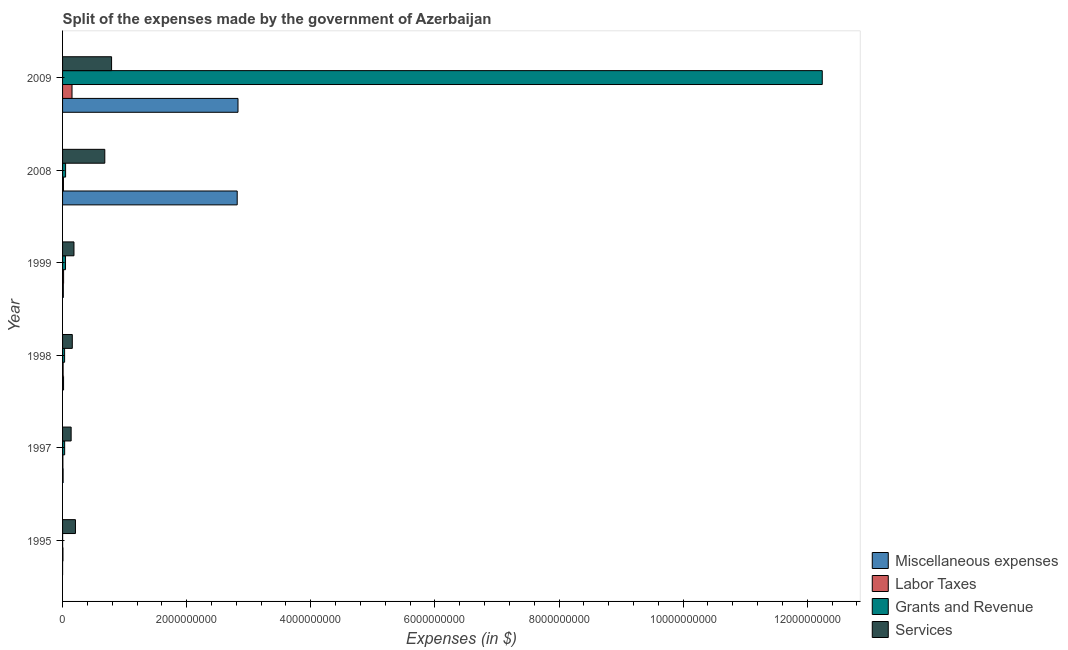Are the number of bars per tick equal to the number of legend labels?
Offer a very short reply. Yes. In how many cases, is the number of bars for a given year not equal to the number of legend labels?
Give a very brief answer. 0. What is the amount spent on miscellaneous expenses in 1999?
Offer a terse response. 1.23e+07. Across all years, what is the maximum amount spent on miscellaneous expenses?
Your answer should be very brief. 2.83e+09. Across all years, what is the minimum amount spent on grants and revenue?
Offer a terse response. 9.45e+05. In which year was the amount spent on labor taxes maximum?
Offer a very short reply. 2009. In which year was the amount spent on miscellaneous expenses minimum?
Make the answer very short. 1995. What is the total amount spent on labor taxes in the graph?
Ensure brevity in your answer.  2.03e+08. What is the difference between the amount spent on grants and revenue in 1999 and that in 2009?
Your response must be concise. -1.22e+1. What is the difference between the amount spent on grants and revenue in 1997 and the amount spent on miscellaneous expenses in 1998?
Make the answer very short. 1.76e+07. What is the average amount spent on miscellaneous expenses per year?
Make the answer very short. 9.46e+08. In the year 2009, what is the difference between the amount spent on miscellaneous expenses and amount spent on labor taxes?
Offer a very short reply. 2.67e+09. What is the ratio of the amount spent on labor taxes in 1997 to that in 1999?
Your answer should be compact. 0.31. Is the amount spent on miscellaneous expenses in 1999 less than that in 2008?
Make the answer very short. Yes. Is the difference between the amount spent on grants and revenue in 1999 and 2008 greater than the difference between the amount spent on labor taxes in 1999 and 2008?
Ensure brevity in your answer.  No. What is the difference between the highest and the second highest amount spent on miscellaneous expenses?
Your response must be concise. 1.29e+07. What is the difference between the highest and the lowest amount spent on miscellaneous expenses?
Your response must be concise. 2.83e+09. What does the 1st bar from the top in 1998 represents?
Keep it short and to the point. Services. What does the 1st bar from the bottom in 1997 represents?
Offer a very short reply. Miscellaneous expenses. How many bars are there?
Keep it short and to the point. 24. What is the difference between two consecutive major ticks on the X-axis?
Your response must be concise. 2.00e+09. Are the values on the major ticks of X-axis written in scientific E-notation?
Your answer should be compact. No. Does the graph contain grids?
Give a very brief answer. No. Where does the legend appear in the graph?
Keep it short and to the point. Bottom right. What is the title of the graph?
Ensure brevity in your answer.  Split of the expenses made by the government of Azerbaijan. Does "Other greenhouse gases" appear as one of the legend labels in the graph?
Ensure brevity in your answer.  No. What is the label or title of the X-axis?
Provide a succinct answer. Expenses (in $). What is the label or title of the Y-axis?
Provide a short and direct response. Year. What is the Expenses (in $) in Miscellaneous expenses in 1995?
Offer a terse response. 3.14e+05. What is the Expenses (in $) of Labor Taxes in 1995?
Offer a very short reply. 6.16e+06. What is the Expenses (in $) in Grants and Revenue in 1995?
Make the answer very short. 9.45e+05. What is the Expenses (in $) of Services in 1995?
Provide a short and direct response. 2.08e+08. What is the Expenses (in $) in Miscellaneous expenses in 1997?
Offer a terse response. 8.71e+06. What is the Expenses (in $) of Labor Taxes in 1997?
Your answer should be compact. 5.17e+06. What is the Expenses (in $) in Grants and Revenue in 1997?
Your answer should be compact. 3.36e+07. What is the Expenses (in $) of Services in 1997?
Keep it short and to the point. 1.38e+08. What is the Expenses (in $) in Miscellaneous expenses in 1998?
Offer a terse response. 1.60e+07. What is the Expenses (in $) of Labor Taxes in 1998?
Offer a terse response. 8.90e+06. What is the Expenses (in $) of Grants and Revenue in 1998?
Ensure brevity in your answer.  3.29e+07. What is the Expenses (in $) of Services in 1998?
Offer a very short reply. 1.57e+08. What is the Expenses (in $) in Miscellaneous expenses in 1999?
Your answer should be compact. 1.23e+07. What is the Expenses (in $) of Labor Taxes in 1999?
Ensure brevity in your answer.  1.66e+07. What is the Expenses (in $) in Grants and Revenue in 1999?
Give a very brief answer. 4.76e+07. What is the Expenses (in $) in Services in 1999?
Give a very brief answer. 1.84e+08. What is the Expenses (in $) in Miscellaneous expenses in 2008?
Offer a terse response. 2.81e+09. What is the Expenses (in $) in Labor Taxes in 2008?
Provide a short and direct response. 1.43e+07. What is the Expenses (in $) in Grants and Revenue in 2008?
Ensure brevity in your answer.  4.87e+07. What is the Expenses (in $) of Services in 2008?
Provide a short and direct response. 6.80e+08. What is the Expenses (in $) in Miscellaneous expenses in 2009?
Make the answer very short. 2.83e+09. What is the Expenses (in $) of Labor Taxes in 2009?
Your answer should be very brief. 1.52e+08. What is the Expenses (in $) of Grants and Revenue in 2009?
Your response must be concise. 1.22e+1. What is the Expenses (in $) in Services in 2009?
Provide a short and direct response. 7.90e+08. Across all years, what is the maximum Expenses (in $) of Miscellaneous expenses?
Make the answer very short. 2.83e+09. Across all years, what is the maximum Expenses (in $) of Labor Taxes?
Keep it short and to the point. 1.52e+08. Across all years, what is the maximum Expenses (in $) in Grants and Revenue?
Your answer should be compact. 1.22e+1. Across all years, what is the maximum Expenses (in $) of Services?
Your response must be concise. 7.90e+08. Across all years, what is the minimum Expenses (in $) of Miscellaneous expenses?
Provide a short and direct response. 3.14e+05. Across all years, what is the minimum Expenses (in $) of Labor Taxes?
Provide a succinct answer. 5.17e+06. Across all years, what is the minimum Expenses (in $) of Grants and Revenue?
Offer a terse response. 9.45e+05. Across all years, what is the minimum Expenses (in $) in Services?
Provide a short and direct response. 1.38e+08. What is the total Expenses (in $) of Miscellaneous expenses in the graph?
Make the answer very short. 5.68e+09. What is the total Expenses (in $) in Labor Taxes in the graph?
Your answer should be very brief. 2.03e+08. What is the total Expenses (in $) of Grants and Revenue in the graph?
Offer a very short reply. 1.24e+1. What is the total Expenses (in $) in Services in the graph?
Ensure brevity in your answer.  2.16e+09. What is the difference between the Expenses (in $) in Miscellaneous expenses in 1995 and that in 1997?
Keep it short and to the point. -8.39e+06. What is the difference between the Expenses (in $) of Labor Taxes in 1995 and that in 1997?
Offer a terse response. 9.89e+05. What is the difference between the Expenses (in $) in Grants and Revenue in 1995 and that in 1997?
Provide a succinct answer. -3.27e+07. What is the difference between the Expenses (in $) of Services in 1995 and that in 1997?
Provide a succinct answer. 6.93e+07. What is the difference between the Expenses (in $) of Miscellaneous expenses in 1995 and that in 1998?
Keep it short and to the point. -1.57e+07. What is the difference between the Expenses (in $) of Labor Taxes in 1995 and that in 1998?
Your response must be concise. -2.74e+06. What is the difference between the Expenses (in $) of Grants and Revenue in 1995 and that in 1998?
Your response must be concise. -3.20e+07. What is the difference between the Expenses (in $) in Services in 1995 and that in 1998?
Ensure brevity in your answer.  5.07e+07. What is the difference between the Expenses (in $) of Miscellaneous expenses in 1995 and that in 1999?
Offer a terse response. -1.20e+07. What is the difference between the Expenses (in $) in Labor Taxes in 1995 and that in 1999?
Make the answer very short. -1.05e+07. What is the difference between the Expenses (in $) in Grants and Revenue in 1995 and that in 1999?
Give a very brief answer. -4.66e+07. What is the difference between the Expenses (in $) in Services in 1995 and that in 1999?
Offer a very short reply. 2.38e+07. What is the difference between the Expenses (in $) in Miscellaneous expenses in 1995 and that in 2008?
Offer a very short reply. -2.81e+09. What is the difference between the Expenses (in $) of Labor Taxes in 1995 and that in 2008?
Your answer should be very brief. -8.10e+06. What is the difference between the Expenses (in $) in Grants and Revenue in 1995 and that in 2008?
Keep it short and to the point. -4.78e+07. What is the difference between the Expenses (in $) of Services in 1995 and that in 2008?
Your answer should be compact. -4.73e+08. What is the difference between the Expenses (in $) in Miscellaneous expenses in 1995 and that in 2009?
Keep it short and to the point. -2.83e+09. What is the difference between the Expenses (in $) in Labor Taxes in 1995 and that in 2009?
Offer a terse response. -1.46e+08. What is the difference between the Expenses (in $) in Grants and Revenue in 1995 and that in 2009?
Provide a short and direct response. -1.22e+1. What is the difference between the Expenses (in $) in Services in 1995 and that in 2009?
Your answer should be compact. -5.82e+08. What is the difference between the Expenses (in $) of Miscellaneous expenses in 1997 and that in 1998?
Your answer should be very brief. -7.34e+06. What is the difference between the Expenses (in $) of Labor Taxes in 1997 and that in 1998?
Provide a succinct answer. -3.73e+06. What is the difference between the Expenses (in $) of Grants and Revenue in 1997 and that in 1998?
Offer a very short reply. 7.00e+05. What is the difference between the Expenses (in $) of Services in 1997 and that in 1998?
Offer a terse response. -1.86e+07. What is the difference between the Expenses (in $) in Miscellaneous expenses in 1997 and that in 1999?
Offer a terse response. -3.57e+06. What is the difference between the Expenses (in $) in Labor Taxes in 1997 and that in 1999?
Keep it short and to the point. -1.14e+07. What is the difference between the Expenses (in $) in Grants and Revenue in 1997 and that in 1999?
Give a very brief answer. -1.40e+07. What is the difference between the Expenses (in $) in Services in 1997 and that in 1999?
Your answer should be compact. -4.55e+07. What is the difference between the Expenses (in $) in Miscellaneous expenses in 1997 and that in 2008?
Keep it short and to the point. -2.81e+09. What is the difference between the Expenses (in $) of Labor Taxes in 1997 and that in 2008?
Keep it short and to the point. -9.09e+06. What is the difference between the Expenses (in $) of Grants and Revenue in 1997 and that in 2008?
Keep it short and to the point. -1.51e+07. What is the difference between the Expenses (in $) of Services in 1997 and that in 2008?
Your answer should be very brief. -5.42e+08. What is the difference between the Expenses (in $) in Miscellaneous expenses in 1997 and that in 2009?
Your answer should be very brief. -2.82e+09. What is the difference between the Expenses (in $) of Labor Taxes in 1997 and that in 2009?
Provide a succinct answer. -1.47e+08. What is the difference between the Expenses (in $) of Grants and Revenue in 1997 and that in 2009?
Offer a terse response. -1.22e+1. What is the difference between the Expenses (in $) of Services in 1997 and that in 2009?
Provide a short and direct response. -6.52e+08. What is the difference between the Expenses (in $) in Miscellaneous expenses in 1998 and that in 1999?
Keep it short and to the point. 3.77e+06. What is the difference between the Expenses (in $) in Labor Taxes in 1998 and that in 1999?
Your answer should be very brief. -7.72e+06. What is the difference between the Expenses (in $) in Grants and Revenue in 1998 and that in 1999?
Ensure brevity in your answer.  -1.47e+07. What is the difference between the Expenses (in $) in Services in 1998 and that in 1999?
Your answer should be very brief. -2.69e+07. What is the difference between the Expenses (in $) of Miscellaneous expenses in 1998 and that in 2008?
Give a very brief answer. -2.80e+09. What is the difference between the Expenses (in $) of Labor Taxes in 1998 and that in 2008?
Keep it short and to the point. -5.36e+06. What is the difference between the Expenses (in $) in Grants and Revenue in 1998 and that in 2008?
Offer a terse response. -1.58e+07. What is the difference between the Expenses (in $) of Services in 1998 and that in 2008?
Provide a succinct answer. -5.24e+08. What is the difference between the Expenses (in $) of Miscellaneous expenses in 1998 and that in 2009?
Keep it short and to the point. -2.81e+09. What is the difference between the Expenses (in $) in Labor Taxes in 1998 and that in 2009?
Keep it short and to the point. -1.43e+08. What is the difference between the Expenses (in $) in Grants and Revenue in 1998 and that in 2009?
Offer a terse response. -1.22e+1. What is the difference between the Expenses (in $) of Services in 1998 and that in 2009?
Your response must be concise. -6.33e+08. What is the difference between the Expenses (in $) of Miscellaneous expenses in 1999 and that in 2008?
Ensure brevity in your answer.  -2.80e+09. What is the difference between the Expenses (in $) of Labor Taxes in 1999 and that in 2008?
Your response must be concise. 2.36e+06. What is the difference between the Expenses (in $) of Grants and Revenue in 1999 and that in 2008?
Offer a very short reply. -1.16e+06. What is the difference between the Expenses (in $) in Services in 1999 and that in 2008?
Your response must be concise. -4.97e+08. What is the difference between the Expenses (in $) in Miscellaneous expenses in 1999 and that in 2009?
Keep it short and to the point. -2.81e+09. What is the difference between the Expenses (in $) of Labor Taxes in 1999 and that in 2009?
Your answer should be very brief. -1.36e+08. What is the difference between the Expenses (in $) of Grants and Revenue in 1999 and that in 2009?
Offer a terse response. -1.22e+1. What is the difference between the Expenses (in $) in Services in 1999 and that in 2009?
Ensure brevity in your answer.  -6.06e+08. What is the difference between the Expenses (in $) of Miscellaneous expenses in 2008 and that in 2009?
Provide a succinct answer. -1.29e+07. What is the difference between the Expenses (in $) in Labor Taxes in 2008 and that in 2009?
Your response must be concise. -1.38e+08. What is the difference between the Expenses (in $) of Grants and Revenue in 2008 and that in 2009?
Your response must be concise. -1.22e+1. What is the difference between the Expenses (in $) of Services in 2008 and that in 2009?
Provide a succinct answer. -1.09e+08. What is the difference between the Expenses (in $) of Miscellaneous expenses in 1995 and the Expenses (in $) of Labor Taxes in 1997?
Keep it short and to the point. -4.86e+06. What is the difference between the Expenses (in $) of Miscellaneous expenses in 1995 and the Expenses (in $) of Grants and Revenue in 1997?
Make the answer very short. -3.33e+07. What is the difference between the Expenses (in $) of Miscellaneous expenses in 1995 and the Expenses (in $) of Services in 1997?
Offer a terse response. -1.38e+08. What is the difference between the Expenses (in $) in Labor Taxes in 1995 and the Expenses (in $) in Grants and Revenue in 1997?
Make the answer very short. -2.74e+07. What is the difference between the Expenses (in $) of Labor Taxes in 1995 and the Expenses (in $) of Services in 1997?
Ensure brevity in your answer.  -1.32e+08. What is the difference between the Expenses (in $) in Grants and Revenue in 1995 and the Expenses (in $) in Services in 1997?
Your answer should be very brief. -1.37e+08. What is the difference between the Expenses (in $) of Miscellaneous expenses in 1995 and the Expenses (in $) of Labor Taxes in 1998?
Make the answer very short. -8.59e+06. What is the difference between the Expenses (in $) of Miscellaneous expenses in 1995 and the Expenses (in $) of Grants and Revenue in 1998?
Provide a succinct answer. -3.26e+07. What is the difference between the Expenses (in $) of Miscellaneous expenses in 1995 and the Expenses (in $) of Services in 1998?
Offer a terse response. -1.57e+08. What is the difference between the Expenses (in $) of Labor Taxes in 1995 and the Expenses (in $) of Grants and Revenue in 1998?
Give a very brief answer. -2.67e+07. What is the difference between the Expenses (in $) of Labor Taxes in 1995 and the Expenses (in $) of Services in 1998?
Give a very brief answer. -1.51e+08. What is the difference between the Expenses (in $) in Grants and Revenue in 1995 and the Expenses (in $) in Services in 1998?
Your answer should be very brief. -1.56e+08. What is the difference between the Expenses (in $) of Miscellaneous expenses in 1995 and the Expenses (in $) of Labor Taxes in 1999?
Provide a short and direct response. -1.63e+07. What is the difference between the Expenses (in $) in Miscellaneous expenses in 1995 and the Expenses (in $) in Grants and Revenue in 1999?
Your answer should be compact. -4.73e+07. What is the difference between the Expenses (in $) in Miscellaneous expenses in 1995 and the Expenses (in $) in Services in 1999?
Offer a very short reply. -1.83e+08. What is the difference between the Expenses (in $) of Labor Taxes in 1995 and the Expenses (in $) of Grants and Revenue in 1999?
Give a very brief answer. -4.14e+07. What is the difference between the Expenses (in $) in Labor Taxes in 1995 and the Expenses (in $) in Services in 1999?
Provide a succinct answer. -1.78e+08. What is the difference between the Expenses (in $) of Grants and Revenue in 1995 and the Expenses (in $) of Services in 1999?
Your answer should be compact. -1.83e+08. What is the difference between the Expenses (in $) in Miscellaneous expenses in 1995 and the Expenses (in $) in Labor Taxes in 2008?
Offer a terse response. -1.39e+07. What is the difference between the Expenses (in $) of Miscellaneous expenses in 1995 and the Expenses (in $) of Grants and Revenue in 2008?
Provide a short and direct response. -4.84e+07. What is the difference between the Expenses (in $) of Miscellaneous expenses in 1995 and the Expenses (in $) of Services in 2008?
Your answer should be compact. -6.80e+08. What is the difference between the Expenses (in $) of Labor Taxes in 1995 and the Expenses (in $) of Grants and Revenue in 2008?
Your answer should be compact. -4.26e+07. What is the difference between the Expenses (in $) in Labor Taxes in 1995 and the Expenses (in $) in Services in 2008?
Offer a very short reply. -6.74e+08. What is the difference between the Expenses (in $) in Grants and Revenue in 1995 and the Expenses (in $) in Services in 2008?
Ensure brevity in your answer.  -6.80e+08. What is the difference between the Expenses (in $) in Miscellaneous expenses in 1995 and the Expenses (in $) in Labor Taxes in 2009?
Your answer should be very brief. -1.52e+08. What is the difference between the Expenses (in $) in Miscellaneous expenses in 1995 and the Expenses (in $) in Grants and Revenue in 2009?
Your response must be concise. -1.22e+1. What is the difference between the Expenses (in $) of Miscellaneous expenses in 1995 and the Expenses (in $) of Services in 2009?
Offer a terse response. -7.89e+08. What is the difference between the Expenses (in $) of Labor Taxes in 1995 and the Expenses (in $) of Grants and Revenue in 2009?
Provide a short and direct response. -1.22e+1. What is the difference between the Expenses (in $) of Labor Taxes in 1995 and the Expenses (in $) of Services in 2009?
Your answer should be compact. -7.84e+08. What is the difference between the Expenses (in $) of Grants and Revenue in 1995 and the Expenses (in $) of Services in 2009?
Ensure brevity in your answer.  -7.89e+08. What is the difference between the Expenses (in $) of Miscellaneous expenses in 1997 and the Expenses (in $) of Labor Taxes in 1998?
Ensure brevity in your answer.  -1.98e+05. What is the difference between the Expenses (in $) of Miscellaneous expenses in 1997 and the Expenses (in $) of Grants and Revenue in 1998?
Your answer should be compact. -2.42e+07. What is the difference between the Expenses (in $) in Miscellaneous expenses in 1997 and the Expenses (in $) in Services in 1998?
Your response must be concise. -1.48e+08. What is the difference between the Expenses (in $) in Labor Taxes in 1997 and the Expenses (in $) in Grants and Revenue in 1998?
Ensure brevity in your answer.  -2.77e+07. What is the difference between the Expenses (in $) of Labor Taxes in 1997 and the Expenses (in $) of Services in 1998?
Offer a terse response. -1.52e+08. What is the difference between the Expenses (in $) in Grants and Revenue in 1997 and the Expenses (in $) in Services in 1998?
Provide a succinct answer. -1.23e+08. What is the difference between the Expenses (in $) in Miscellaneous expenses in 1997 and the Expenses (in $) in Labor Taxes in 1999?
Provide a short and direct response. -7.91e+06. What is the difference between the Expenses (in $) in Miscellaneous expenses in 1997 and the Expenses (in $) in Grants and Revenue in 1999?
Provide a succinct answer. -3.89e+07. What is the difference between the Expenses (in $) of Miscellaneous expenses in 1997 and the Expenses (in $) of Services in 1999?
Offer a terse response. -1.75e+08. What is the difference between the Expenses (in $) in Labor Taxes in 1997 and the Expenses (in $) in Grants and Revenue in 1999?
Offer a terse response. -4.24e+07. What is the difference between the Expenses (in $) in Labor Taxes in 1997 and the Expenses (in $) in Services in 1999?
Keep it short and to the point. -1.79e+08. What is the difference between the Expenses (in $) in Grants and Revenue in 1997 and the Expenses (in $) in Services in 1999?
Your response must be concise. -1.50e+08. What is the difference between the Expenses (in $) of Miscellaneous expenses in 1997 and the Expenses (in $) of Labor Taxes in 2008?
Your response must be concise. -5.56e+06. What is the difference between the Expenses (in $) in Miscellaneous expenses in 1997 and the Expenses (in $) in Grants and Revenue in 2008?
Your answer should be compact. -4.00e+07. What is the difference between the Expenses (in $) in Miscellaneous expenses in 1997 and the Expenses (in $) in Services in 2008?
Give a very brief answer. -6.72e+08. What is the difference between the Expenses (in $) of Labor Taxes in 1997 and the Expenses (in $) of Grants and Revenue in 2008?
Your response must be concise. -4.36e+07. What is the difference between the Expenses (in $) in Labor Taxes in 1997 and the Expenses (in $) in Services in 2008?
Keep it short and to the point. -6.75e+08. What is the difference between the Expenses (in $) of Grants and Revenue in 1997 and the Expenses (in $) of Services in 2008?
Your answer should be compact. -6.47e+08. What is the difference between the Expenses (in $) in Miscellaneous expenses in 1997 and the Expenses (in $) in Labor Taxes in 2009?
Provide a short and direct response. -1.43e+08. What is the difference between the Expenses (in $) of Miscellaneous expenses in 1997 and the Expenses (in $) of Grants and Revenue in 2009?
Offer a very short reply. -1.22e+1. What is the difference between the Expenses (in $) in Miscellaneous expenses in 1997 and the Expenses (in $) in Services in 2009?
Your answer should be compact. -7.81e+08. What is the difference between the Expenses (in $) in Labor Taxes in 1997 and the Expenses (in $) in Grants and Revenue in 2009?
Your response must be concise. -1.22e+1. What is the difference between the Expenses (in $) of Labor Taxes in 1997 and the Expenses (in $) of Services in 2009?
Keep it short and to the point. -7.85e+08. What is the difference between the Expenses (in $) of Grants and Revenue in 1997 and the Expenses (in $) of Services in 2009?
Provide a short and direct response. -7.56e+08. What is the difference between the Expenses (in $) of Miscellaneous expenses in 1998 and the Expenses (in $) of Labor Taxes in 1999?
Provide a short and direct response. -5.70e+05. What is the difference between the Expenses (in $) of Miscellaneous expenses in 1998 and the Expenses (in $) of Grants and Revenue in 1999?
Offer a terse response. -3.15e+07. What is the difference between the Expenses (in $) of Miscellaneous expenses in 1998 and the Expenses (in $) of Services in 1999?
Ensure brevity in your answer.  -1.68e+08. What is the difference between the Expenses (in $) in Labor Taxes in 1998 and the Expenses (in $) in Grants and Revenue in 1999?
Your answer should be compact. -3.87e+07. What is the difference between the Expenses (in $) of Labor Taxes in 1998 and the Expenses (in $) of Services in 1999?
Ensure brevity in your answer.  -1.75e+08. What is the difference between the Expenses (in $) in Grants and Revenue in 1998 and the Expenses (in $) in Services in 1999?
Ensure brevity in your answer.  -1.51e+08. What is the difference between the Expenses (in $) in Miscellaneous expenses in 1998 and the Expenses (in $) in Labor Taxes in 2008?
Give a very brief answer. 1.79e+06. What is the difference between the Expenses (in $) of Miscellaneous expenses in 1998 and the Expenses (in $) of Grants and Revenue in 2008?
Your answer should be compact. -3.27e+07. What is the difference between the Expenses (in $) in Miscellaneous expenses in 1998 and the Expenses (in $) in Services in 2008?
Ensure brevity in your answer.  -6.64e+08. What is the difference between the Expenses (in $) in Labor Taxes in 1998 and the Expenses (in $) in Grants and Revenue in 2008?
Offer a very short reply. -3.98e+07. What is the difference between the Expenses (in $) in Labor Taxes in 1998 and the Expenses (in $) in Services in 2008?
Ensure brevity in your answer.  -6.72e+08. What is the difference between the Expenses (in $) of Grants and Revenue in 1998 and the Expenses (in $) of Services in 2008?
Your answer should be compact. -6.48e+08. What is the difference between the Expenses (in $) in Miscellaneous expenses in 1998 and the Expenses (in $) in Labor Taxes in 2009?
Offer a very short reply. -1.36e+08. What is the difference between the Expenses (in $) of Miscellaneous expenses in 1998 and the Expenses (in $) of Grants and Revenue in 2009?
Offer a very short reply. -1.22e+1. What is the difference between the Expenses (in $) in Miscellaneous expenses in 1998 and the Expenses (in $) in Services in 2009?
Give a very brief answer. -7.74e+08. What is the difference between the Expenses (in $) in Labor Taxes in 1998 and the Expenses (in $) in Grants and Revenue in 2009?
Provide a succinct answer. -1.22e+1. What is the difference between the Expenses (in $) in Labor Taxes in 1998 and the Expenses (in $) in Services in 2009?
Make the answer very short. -7.81e+08. What is the difference between the Expenses (in $) in Grants and Revenue in 1998 and the Expenses (in $) in Services in 2009?
Offer a very short reply. -7.57e+08. What is the difference between the Expenses (in $) in Miscellaneous expenses in 1999 and the Expenses (in $) in Labor Taxes in 2008?
Your response must be concise. -1.98e+06. What is the difference between the Expenses (in $) of Miscellaneous expenses in 1999 and the Expenses (in $) of Grants and Revenue in 2008?
Your response must be concise. -3.65e+07. What is the difference between the Expenses (in $) in Miscellaneous expenses in 1999 and the Expenses (in $) in Services in 2008?
Offer a very short reply. -6.68e+08. What is the difference between the Expenses (in $) of Labor Taxes in 1999 and the Expenses (in $) of Grants and Revenue in 2008?
Keep it short and to the point. -3.21e+07. What is the difference between the Expenses (in $) of Labor Taxes in 1999 and the Expenses (in $) of Services in 2008?
Offer a very short reply. -6.64e+08. What is the difference between the Expenses (in $) of Grants and Revenue in 1999 and the Expenses (in $) of Services in 2008?
Make the answer very short. -6.33e+08. What is the difference between the Expenses (in $) of Miscellaneous expenses in 1999 and the Expenses (in $) of Labor Taxes in 2009?
Provide a succinct answer. -1.40e+08. What is the difference between the Expenses (in $) of Miscellaneous expenses in 1999 and the Expenses (in $) of Grants and Revenue in 2009?
Make the answer very short. -1.22e+1. What is the difference between the Expenses (in $) of Miscellaneous expenses in 1999 and the Expenses (in $) of Services in 2009?
Your response must be concise. -7.78e+08. What is the difference between the Expenses (in $) in Labor Taxes in 1999 and the Expenses (in $) in Grants and Revenue in 2009?
Your answer should be very brief. -1.22e+1. What is the difference between the Expenses (in $) of Labor Taxes in 1999 and the Expenses (in $) of Services in 2009?
Give a very brief answer. -7.73e+08. What is the difference between the Expenses (in $) in Grants and Revenue in 1999 and the Expenses (in $) in Services in 2009?
Provide a short and direct response. -7.42e+08. What is the difference between the Expenses (in $) of Miscellaneous expenses in 2008 and the Expenses (in $) of Labor Taxes in 2009?
Offer a terse response. 2.66e+09. What is the difference between the Expenses (in $) of Miscellaneous expenses in 2008 and the Expenses (in $) of Grants and Revenue in 2009?
Give a very brief answer. -9.43e+09. What is the difference between the Expenses (in $) of Miscellaneous expenses in 2008 and the Expenses (in $) of Services in 2009?
Keep it short and to the point. 2.02e+09. What is the difference between the Expenses (in $) in Labor Taxes in 2008 and the Expenses (in $) in Grants and Revenue in 2009?
Give a very brief answer. -1.22e+1. What is the difference between the Expenses (in $) of Labor Taxes in 2008 and the Expenses (in $) of Services in 2009?
Give a very brief answer. -7.76e+08. What is the difference between the Expenses (in $) of Grants and Revenue in 2008 and the Expenses (in $) of Services in 2009?
Offer a terse response. -7.41e+08. What is the average Expenses (in $) of Miscellaneous expenses per year?
Provide a short and direct response. 9.46e+08. What is the average Expenses (in $) in Labor Taxes per year?
Provide a short and direct response. 3.39e+07. What is the average Expenses (in $) in Grants and Revenue per year?
Provide a succinct answer. 2.07e+09. What is the average Expenses (in $) in Services per year?
Keep it short and to the point. 3.59e+08. In the year 1995, what is the difference between the Expenses (in $) of Miscellaneous expenses and Expenses (in $) of Labor Taxes?
Make the answer very short. -5.85e+06. In the year 1995, what is the difference between the Expenses (in $) in Miscellaneous expenses and Expenses (in $) in Grants and Revenue?
Provide a succinct answer. -6.31e+05. In the year 1995, what is the difference between the Expenses (in $) of Miscellaneous expenses and Expenses (in $) of Services?
Give a very brief answer. -2.07e+08. In the year 1995, what is the difference between the Expenses (in $) in Labor Taxes and Expenses (in $) in Grants and Revenue?
Offer a terse response. 5.22e+06. In the year 1995, what is the difference between the Expenses (in $) of Labor Taxes and Expenses (in $) of Services?
Ensure brevity in your answer.  -2.01e+08. In the year 1995, what is the difference between the Expenses (in $) of Grants and Revenue and Expenses (in $) of Services?
Offer a terse response. -2.07e+08. In the year 1997, what is the difference between the Expenses (in $) of Miscellaneous expenses and Expenses (in $) of Labor Taxes?
Your response must be concise. 3.54e+06. In the year 1997, what is the difference between the Expenses (in $) in Miscellaneous expenses and Expenses (in $) in Grants and Revenue?
Your answer should be very brief. -2.49e+07. In the year 1997, what is the difference between the Expenses (in $) of Miscellaneous expenses and Expenses (in $) of Services?
Give a very brief answer. -1.30e+08. In the year 1997, what is the difference between the Expenses (in $) of Labor Taxes and Expenses (in $) of Grants and Revenue?
Keep it short and to the point. -2.84e+07. In the year 1997, what is the difference between the Expenses (in $) of Labor Taxes and Expenses (in $) of Services?
Give a very brief answer. -1.33e+08. In the year 1997, what is the difference between the Expenses (in $) of Grants and Revenue and Expenses (in $) of Services?
Keep it short and to the point. -1.05e+08. In the year 1998, what is the difference between the Expenses (in $) of Miscellaneous expenses and Expenses (in $) of Labor Taxes?
Ensure brevity in your answer.  7.14e+06. In the year 1998, what is the difference between the Expenses (in $) in Miscellaneous expenses and Expenses (in $) in Grants and Revenue?
Your answer should be very brief. -1.68e+07. In the year 1998, what is the difference between the Expenses (in $) of Miscellaneous expenses and Expenses (in $) of Services?
Provide a short and direct response. -1.41e+08. In the year 1998, what is the difference between the Expenses (in $) in Labor Taxes and Expenses (in $) in Grants and Revenue?
Provide a short and direct response. -2.40e+07. In the year 1998, what is the difference between the Expenses (in $) in Labor Taxes and Expenses (in $) in Services?
Your response must be concise. -1.48e+08. In the year 1998, what is the difference between the Expenses (in $) in Grants and Revenue and Expenses (in $) in Services?
Make the answer very short. -1.24e+08. In the year 1999, what is the difference between the Expenses (in $) of Miscellaneous expenses and Expenses (in $) of Labor Taxes?
Your response must be concise. -4.34e+06. In the year 1999, what is the difference between the Expenses (in $) of Miscellaneous expenses and Expenses (in $) of Grants and Revenue?
Offer a very short reply. -3.53e+07. In the year 1999, what is the difference between the Expenses (in $) in Miscellaneous expenses and Expenses (in $) in Services?
Provide a succinct answer. -1.71e+08. In the year 1999, what is the difference between the Expenses (in $) of Labor Taxes and Expenses (in $) of Grants and Revenue?
Keep it short and to the point. -3.10e+07. In the year 1999, what is the difference between the Expenses (in $) of Labor Taxes and Expenses (in $) of Services?
Make the answer very short. -1.67e+08. In the year 1999, what is the difference between the Expenses (in $) of Grants and Revenue and Expenses (in $) of Services?
Make the answer very short. -1.36e+08. In the year 2008, what is the difference between the Expenses (in $) in Miscellaneous expenses and Expenses (in $) in Labor Taxes?
Make the answer very short. 2.80e+09. In the year 2008, what is the difference between the Expenses (in $) of Miscellaneous expenses and Expenses (in $) of Grants and Revenue?
Your response must be concise. 2.77e+09. In the year 2008, what is the difference between the Expenses (in $) in Miscellaneous expenses and Expenses (in $) in Services?
Offer a very short reply. 2.13e+09. In the year 2008, what is the difference between the Expenses (in $) of Labor Taxes and Expenses (in $) of Grants and Revenue?
Offer a very short reply. -3.45e+07. In the year 2008, what is the difference between the Expenses (in $) in Labor Taxes and Expenses (in $) in Services?
Your answer should be very brief. -6.66e+08. In the year 2008, what is the difference between the Expenses (in $) of Grants and Revenue and Expenses (in $) of Services?
Offer a terse response. -6.32e+08. In the year 2009, what is the difference between the Expenses (in $) of Miscellaneous expenses and Expenses (in $) of Labor Taxes?
Offer a terse response. 2.67e+09. In the year 2009, what is the difference between the Expenses (in $) of Miscellaneous expenses and Expenses (in $) of Grants and Revenue?
Your answer should be compact. -9.42e+09. In the year 2009, what is the difference between the Expenses (in $) of Miscellaneous expenses and Expenses (in $) of Services?
Provide a succinct answer. 2.04e+09. In the year 2009, what is the difference between the Expenses (in $) of Labor Taxes and Expenses (in $) of Grants and Revenue?
Your response must be concise. -1.21e+1. In the year 2009, what is the difference between the Expenses (in $) of Labor Taxes and Expenses (in $) of Services?
Keep it short and to the point. -6.38e+08. In the year 2009, what is the difference between the Expenses (in $) in Grants and Revenue and Expenses (in $) in Services?
Provide a succinct answer. 1.15e+1. What is the ratio of the Expenses (in $) in Miscellaneous expenses in 1995 to that in 1997?
Provide a short and direct response. 0.04. What is the ratio of the Expenses (in $) in Labor Taxes in 1995 to that in 1997?
Your answer should be compact. 1.19. What is the ratio of the Expenses (in $) in Grants and Revenue in 1995 to that in 1997?
Ensure brevity in your answer.  0.03. What is the ratio of the Expenses (in $) in Services in 1995 to that in 1997?
Give a very brief answer. 1.5. What is the ratio of the Expenses (in $) in Miscellaneous expenses in 1995 to that in 1998?
Ensure brevity in your answer.  0.02. What is the ratio of the Expenses (in $) in Labor Taxes in 1995 to that in 1998?
Give a very brief answer. 0.69. What is the ratio of the Expenses (in $) of Grants and Revenue in 1995 to that in 1998?
Offer a terse response. 0.03. What is the ratio of the Expenses (in $) in Services in 1995 to that in 1998?
Ensure brevity in your answer.  1.32. What is the ratio of the Expenses (in $) of Miscellaneous expenses in 1995 to that in 1999?
Provide a succinct answer. 0.03. What is the ratio of the Expenses (in $) of Labor Taxes in 1995 to that in 1999?
Your response must be concise. 0.37. What is the ratio of the Expenses (in $) in Grants and Revenue in 1995 to that in 1999?
Make the answer very short. 0.02. What is the ratio of the Expenses (in $) of Services in 1995 to that in 1999?
Ensure brevity in your answer.  1.13. What is the ratio of the Expenses (in $) of Miscellaneous expenses in 1995 to that in 2008?
Keep it short and to the point. 0. What is the ratio of the Expenses (in $) in Labor Taxes in 1995 to that in 2008?
Make the answer very short. 0.43. What is the ratio of the Expenses (in $) of Grants and Revenue in 1995 to that in 2008?
Provide a short and direct response. 0.02. What is the ratio of the Expenses (in $) in Services in 1995 to that in 2008?
Your answer should be very brief. 0.3. What is the ratio of the Expenses (in $) of Miscellaneous expenses in 1995 to that in 2009?
Your answer should be compact. 0. What is the ratio of the Expenses (in $) of Labor Taxes in 1995 to that in 2009?
Give a very brief answer. 0.04. What is the ratio of the Expenses (in $) of Grants and Revenue in 1995 to that in 2009?
Provide a short and direct response. 0. What is the ratio of the Expenses (in $) in Services in 1995 to that in 2009?
Ensure brevity in your answer.  0.26. What is the ratio of the Expenses (in $) of Miscellaneous expenses in 1997 to that in 1998?
Give a very brief answer. 0.54. What is the ratio of the Expenses (in $) of Labor Taxes in 1997 to that in 1998?
Your answer should be very brief. 0.58. What is the ratio of the Expenses (in $) in Grants and Revenue in 1997 to that in 1998?
Ensure brevity in your answer.  1.02. What is the ratio of the Expenses (in $) of Services in 1997 to that in 1998?
Keep it short and to the point. 0.88. What is the ratio of the Expenses (in $) in Miscellaneous expenses in 1997 to that in 1999?
Your response must be concise. 0.71. What is the ratio of the Expenses (in $) of Labor Taxes in 1997 to that in 1999?
Make the answer very short. 0.31. What is the ratio of the Expenses (in $) of Grants and Revenue in 1997 to that in 1999?
Keep it short and to the point. 0.71. What is the ratio of the Expenses (in $) in Services in 1997 to that in 1999?
Keep it short and to the point. 0.75. What is the ratio of the Expenses (in $) in Miscellaneous expenses in 1997 to that in 2008?
Make the answer very short. 0. What is the ratio of the Expenses (in $) in Labor Taxes in 1997 to that in 2008?
Your answer should be very brief. 0.36. What is the ratio of the Expenses (in $) of Grants and Revenue in 1997 to that in 2008?
Your response must be concise. 0.69. What is the ratio of the Expenses (in $) in Services in 1997 to that in 2008?
Provide a succinct answer. 0.2. What is the ratio of the Expenses (in $) of Miscellaneous expenses in 1997 to that in 2009?
Keep it short and to the point. 0. What is the ratio of the Expenses (in $) in Labor Taxes in 1997 to that in 2009?
Ensure brevity in your answer.  0.03. What is the ratio of the Expenses (in $) of Grants and Revenue in 1997 to that in 2009?
Offer a very short reply. 0. What is the ratio of the Expenses (in $) of Services in 1997 to that in 2009?
Your response must be concise. 0.17. What is the ratio of the Expenses (in $) of Miscellaneous expenses in 1998 to that in 1999?
Your response must be concise. 1.31. What is the ratio of the Expenses (in $) of Labor Taxes in 1998 to that in 1999?
Offer a terse response. 0.54. What is the ratio of the Expenses (in $) of Grants and Revenue in 1998 to that in 1999?
Your answer should be compact. 0.69. What is the ratio of the Expenses (in $) in Services in 1998 to that in 1999?
Make the answer very short. 0.85. What is the ratio of the Expenses (in $) of Miscellaneous expenses in 1998 to that in 2008?
Provide a short and direct response. 0.01. What is the ratio of the Expenses (in $) of Labor Taxes in 1998 to that in 2008?
Provide a short and direct response. 0.62. What is the ratio of the Expenses (in $) of Grants and Revenue in 1998 to that in 2008?
Your response must be concise. 0.68. What is the ratio of the Expenses (in $) in Services in 1998 to that in 2008?
Provide a short and direct response. 0.23. What is the ratio of the Expenses (in $) in Miscellaneous expenses in 1998 to that in 2009?
Give a very brief answer. 0.01. What is the ratio of the Expenses (in $) in Labor Taxes in 1998 to that in 2009?
Ensure brevity in your answer.  0.06. What is the ratio of the Expenses (in $) in Grants and Revenue in 1998 to that in 2009?
Give a very brief answer. 0. What is the ratio of the Expenses (in $) of Services in 1998 to that in 2009?
Provide a succinct answer. 0.2. What is the ratio of the Expenses (in $) of Miscellaneous expenses in 1999 to that in 2008?
Offer a terse response. 0. What is the ratio of the Expenses (in $) in Labor Taxes in 1999 to that in 2008?
Ensure brevity in your answer.  1.17. What is the ratio of the Expenses (in $) of Grants and Revenue in 1999 to that in 2008?
Your response must be concise. 0.98. What is the ratio of the Expenses (in $) of Services in 1999 to that in 2008?
Offer a very short reply. 0.27. What is the ratio of the Expenses (in $) in Miscellaneous expenses in 1999 to that in 2009?
Provide a succinct answer. 0. What is the ratio of the Expenses (in $) of Labor Taxes in 1999 to that in 2009?
Offer a terse response. 0.11. What is the ratio of the Expenses (in $) in Grants and Revenue in 1999 to that in 2009?
Give a very brief answer. 0. What is the ratio of the Expenses (in $) of Services in 1999 to that in 2009?
Ensure brevity in your answer.  0.23. What is the ratio of the Expenses (in $) in Labor Taxes in 2008 to that in 2009?
Provide a succinct answer. 0.09. What is the ratio of the Expenses (in $) in Grants and Revenue in 2008 to that in 2009?
Keep it short and to the point. 0. What is the ratio of the Expenses (in $) of Services in 2008 to that in 2009?
Provide a short and direct response. 0.86. What is the difference between the highest and the second highest Expenses (in $) in Miscellaneous expenses?
Keep it short and to the point. 1.29e+07. What is the difference between the highest and the second highest Expenses (in $) of Labor Taxes?
Your response must be concise. 1.36e+08. What is the difference between the highest and the second highest Expenses (in $) in Grants and Revenue?
Make the answer very short. 1.22e+1. What is the difference between the highest and the second highest Expenses (in $) in Services?
Your answer should be very brief. 1.09e+08. What is the difference between the highest and the lowest Expenses (in $) in Miscellaneous expenses?
Keep it short and to the point. 2.83e+09. What is the difference between the highest and the lowest Expenses (in $) in Labor Taxes?
Give a very brief answer. 1.47e+08. What is the difference between the highest and the lowest Expenses (in $) of Grants and Revenue?
Provide a short and direct response. 1.22e+1. What is the difference between the highest and the lowest Expenses (in $) in Services?
Offer a very short reply. 6.52e+08. 